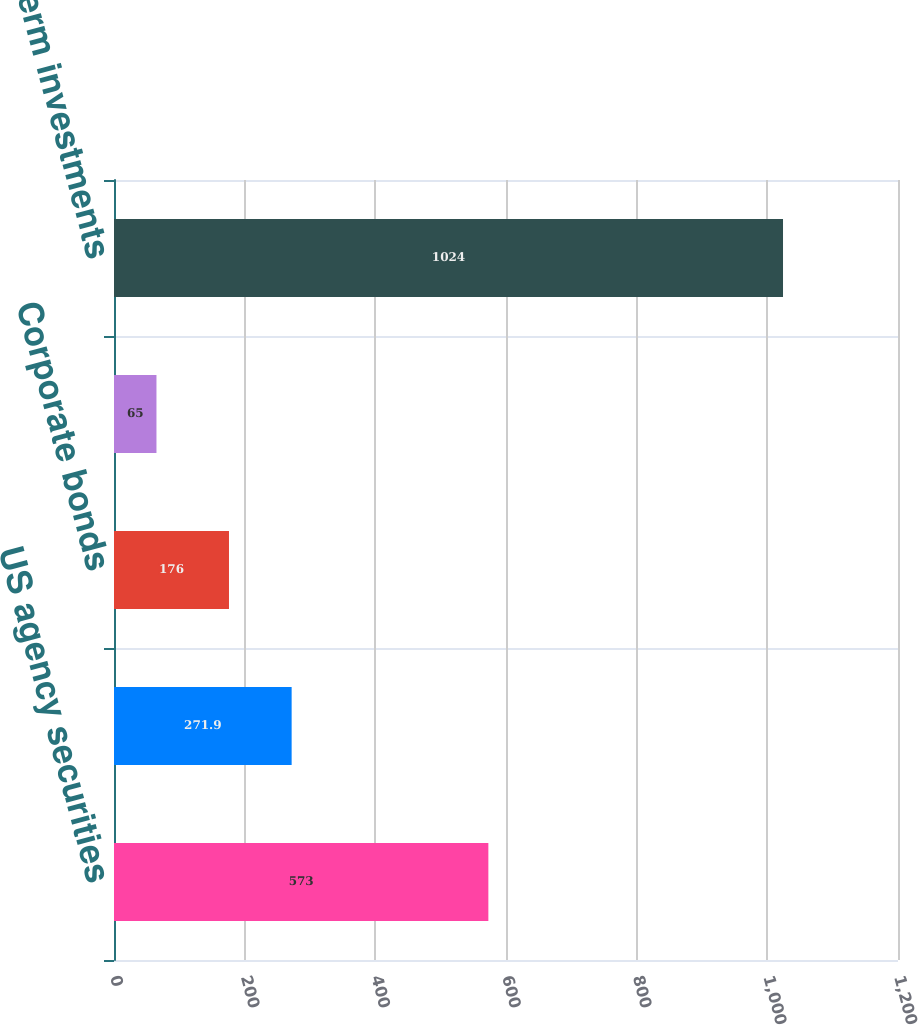<chart> <loc_0><loc_0><loc_500><loc_500><bar_chart><fcel>US agency securities<fcel>US Treasury securities<fcel>Corporate bonds<fcel>Asset-backed and other debt<fcel>Total short-term investments<nl><fcel>573<fcel>271.9<fcel>176<fcel>65<fcel>1024<nl></chart> 